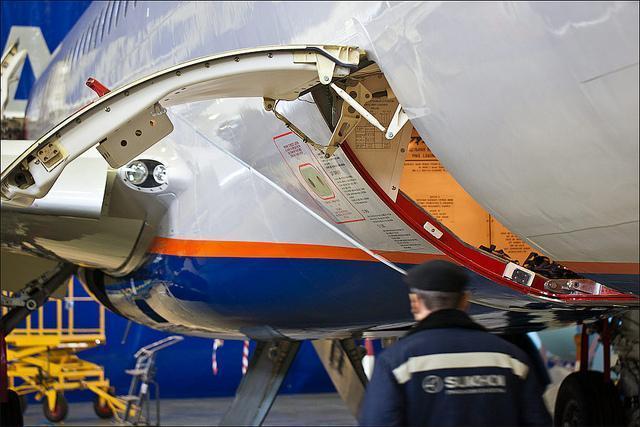How many ties are there?
Give a very brief answer. 0. 